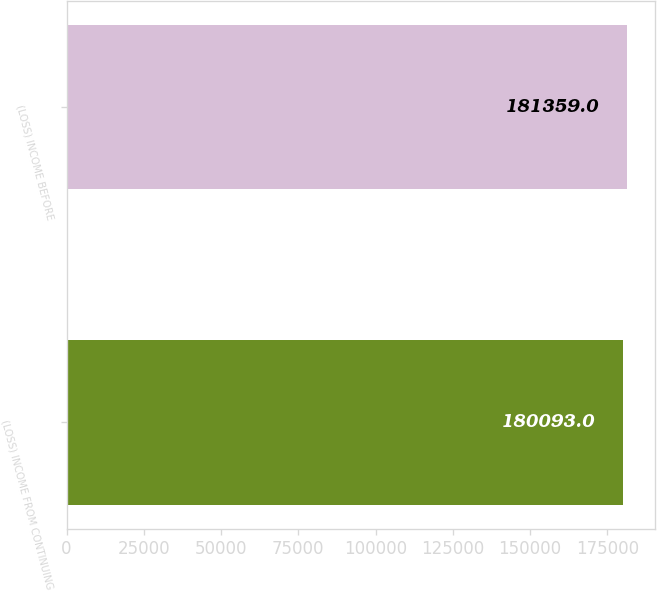<chart> <loc_0><loc_0><loc_500><loc_500><bar_chart><fcel>(LOSS) INCOME FROM CONTINUING<fcel>(LOSS) INCOME BEFORE<nl><fcel>180093<fcel>181359<nl></chart> 